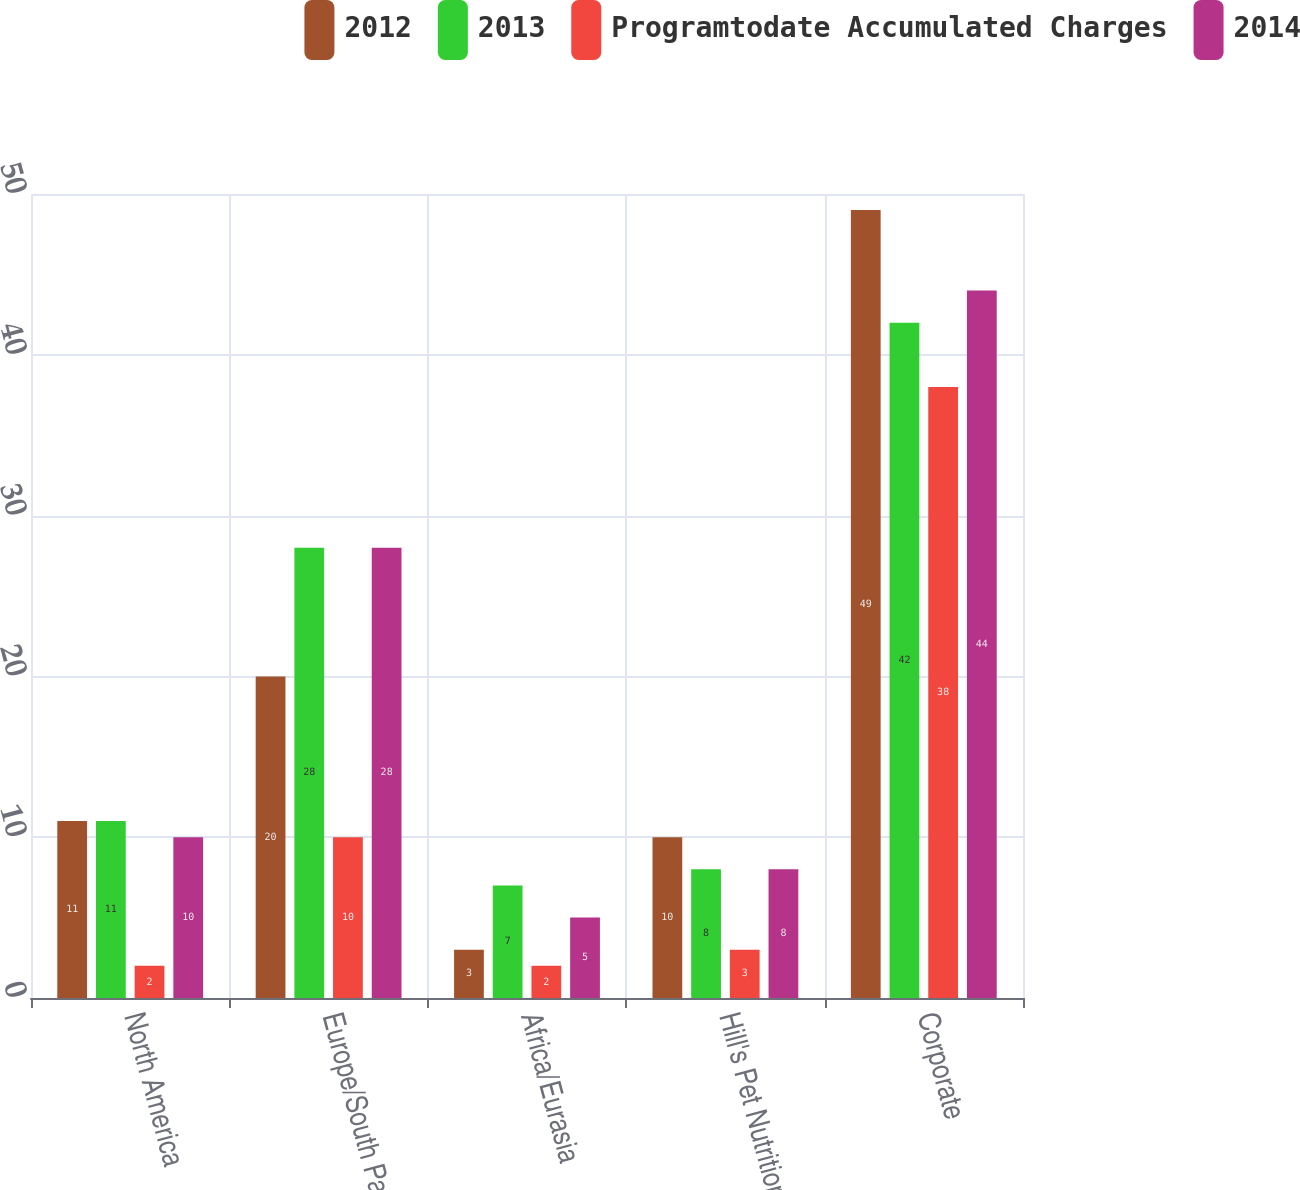<chart> <loc_0><loc_0><loc_500><loc_500><stacked_bar_chart><ecel><fcel>North America<fcel>Europe/South Pacific<fcel>Africa/Eurasia<fcel>Hill's Pet Nutrition<fcel>Corporate<nl><fcel>2012<fcel>11<fcel>20<fcel>3<fcel>10<fcel>49<nl><fcel>2013<fcel>11<fcel>28<fcel>7<fcel>8<fcel>42<nl><fcel>Programtodate Accumulated Charges<fcel>2<fcel>10<fcel>2<fcel>3<fcel>38<nl><fcel>2014<fcel>10<fcel>28<fcel>5<fcel>8<fcel>44<nl></chart> 